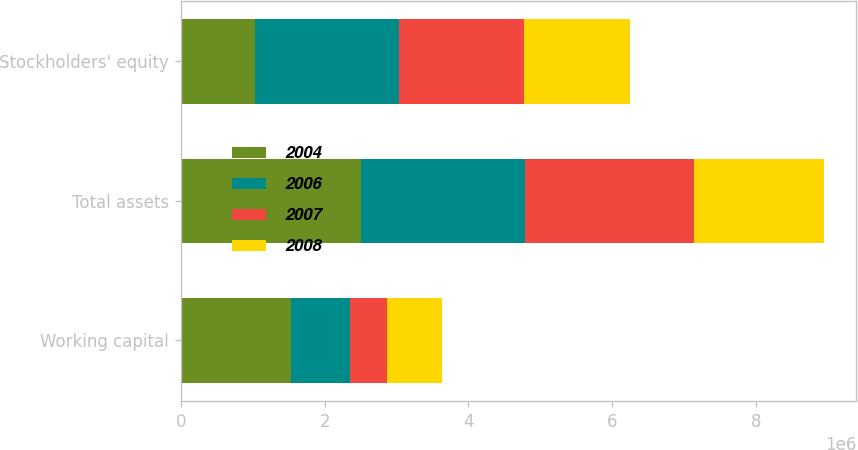<chart> <loc_0><loc_0><loc_500><loc_500><stacked_bar_chart><ecel><fcel>Working capital<fcel>Total assets<fcel>Stockholders' equity<nl><fcel>2004<fcel>1.52665e+06<fcel>2.51231e+06<fcel>1.03622e+06<nl><fcel>2006<fcel>828817<fcel>2.26954e+06<fcel>2.00437e+06<nl><fcel>2007<fcel>509860<fcel>2.3506e+06<fcel>1.72619e+06<nl><fcel>2008<fcel>768683<fcel>1.81755e+06<fcel>1.48573e+06<nl></chart> 